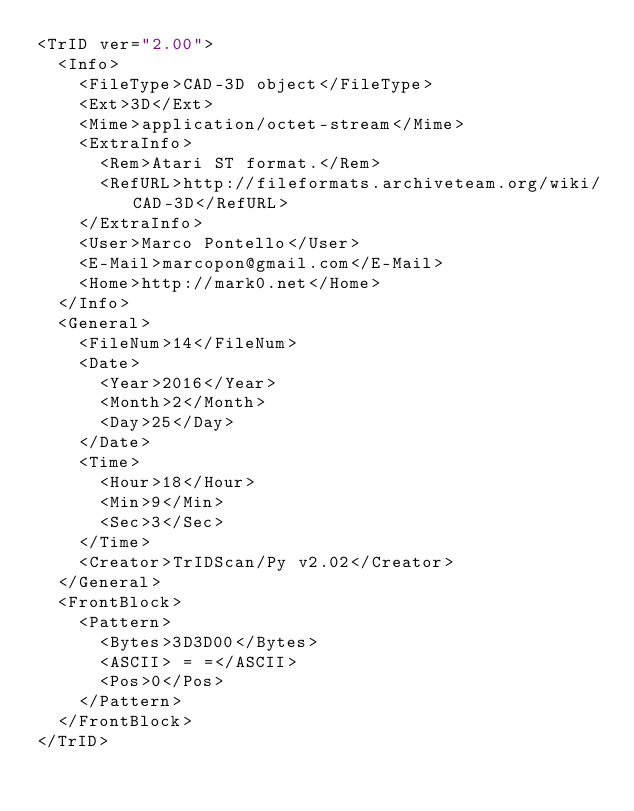<code> <loc_0><loc_0><loc_500><loc_500><_XML_><TrID ver="2.00">
	<Info>
		<FileType>CAD-3D object</FileType>
		<Ext>3D</Ext>
		<Mime>application/octet-stream</Mime>
		<ExtraInfo>
			<Rem>Atari ST format.</Rem>
			<RefURL>http://fileformats.archiveteam.org/wiki/CAD-3D</RefURL>
		</ExtraInfo>
		<User>Marco Pontello</User>
		<E-Mail>marcopon@gmail.com</E-Mail>
		<Home>http://mark0.net</Home>
	</Info>
	<General>
		<FileNum>14</FileNum>
		<Date>
			<Year>2016</Year>
			<Month>2</Month>
			<Day>25</Day>
		</Date>
		<Time>
			<Hour>18</Hour>
			<Min>9</Min>
			<Sec>3</Sec>
		</Time>
		<Creator>TrIDScan/Py v2.02</Creator>
	</General>
	<FrontBlock>
		<Pattern>
			<Bytes>3D3D00</Bytes>
			<ASCII> = =</ASCII>
			<Pos>0</Pos>
		</Pattern>
	</FrontBlock>
</TrID></code> 